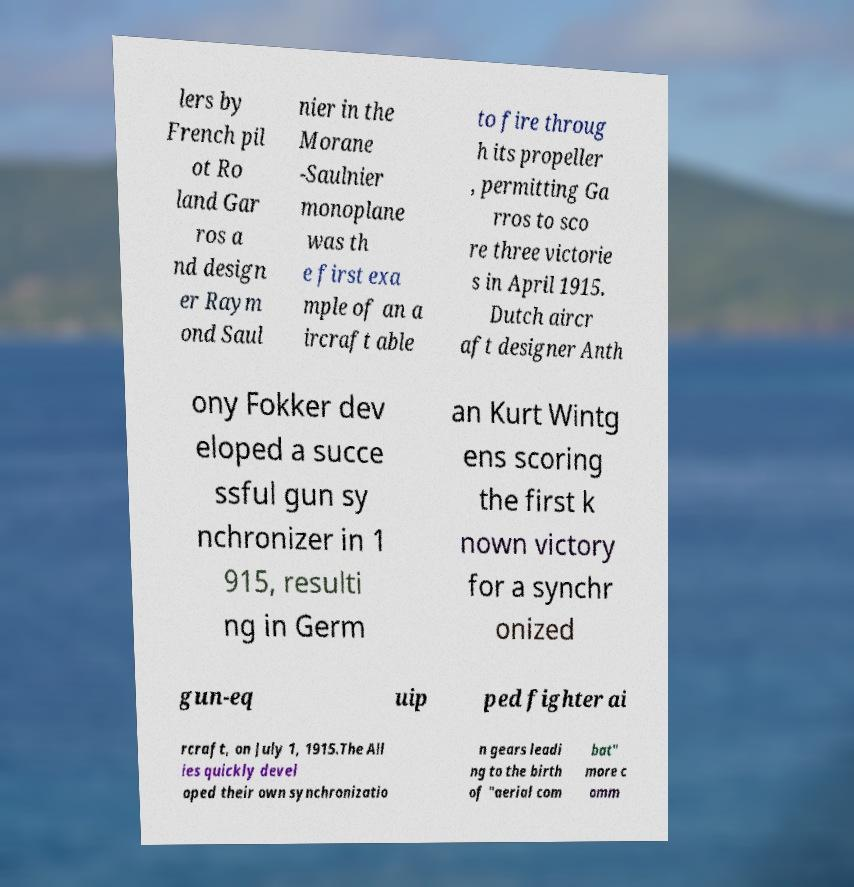For documentation purposes, I need the text within this image transcribed. Could you provide that? lers by French pil ot Ro land Gar ros a nd design er Raym ond Saul nier in the Morane -Saulnier monoplane was th e first exa mple of an a ircraft able to fire throug h its propeller , permitting Ga rros to sco re three victorie s in April 1915. Dutch aircr aft designer Anth ony Fokker dev eloped a succe ssful gun sy nchronizer in 1 915, resulti ng in Germ an Kurt Wintg ens scoring the first k nown victory for a synchr onized gun-eq uip ped fighter ai rcraft, on July 1, 1915.The All ies quickly devel oped their own synchronizatio n gears leadi ng to the birth of "aerial com bat" more c omm 